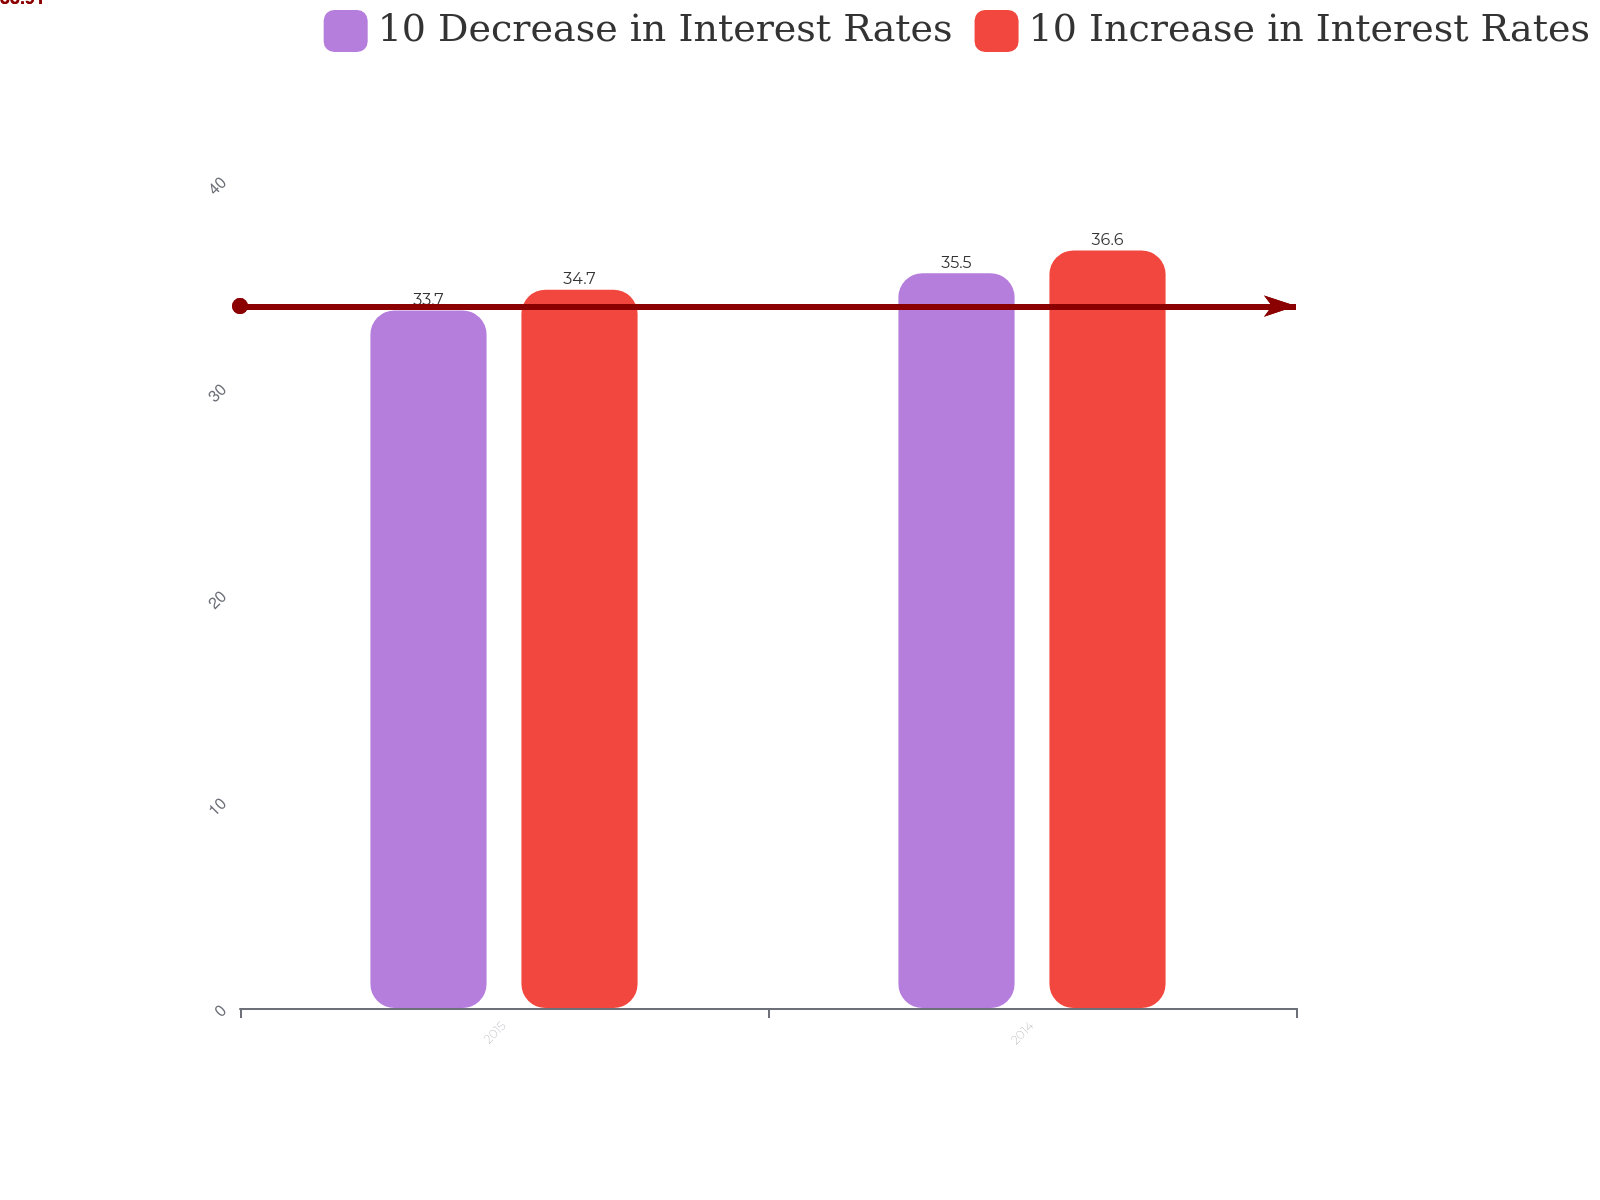<chart> <loc_0><loc_0><loc_500><loc_500><stacked_bar_chart><ecel><fcel>2015<fcel>2014<nl><fcel>10 Decrease in Interest Rates<fcel>33.7<fcel>35.5<nl><fcel>10 Increase in Interest Rates<fcel>34.7<fcel>36.6<nl></chart> 